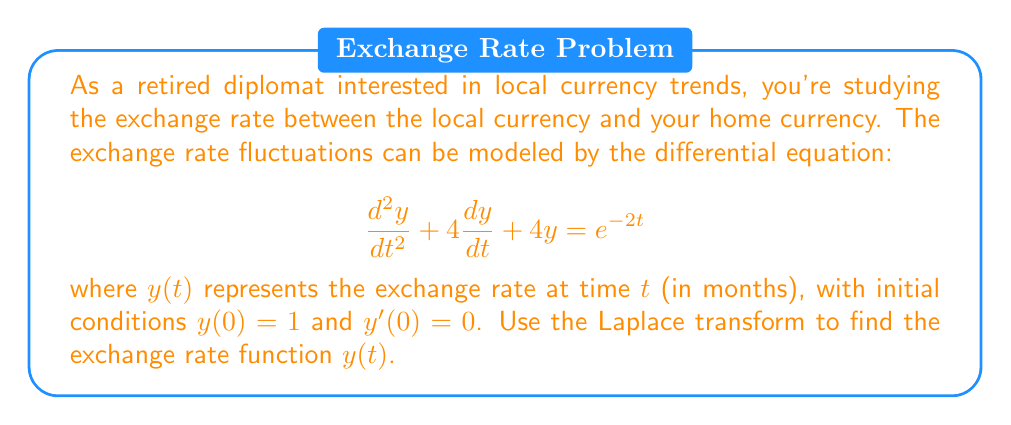Solve this math problem. Let's solve this step-by-step using the Laplace transform:

1) Take the Laplace transform of both sides of the equation:
   $$\mathcal{L}\{\frac{d^2y}{dt^2} + 4\frac{dy}{dt} + 4y\} = \mathcal{L}\{e^{-2t}\}$$

2) Using Laplace transform properties:
   $$[s^2Y(s) - sy(0) - y'(0)] + 4[sY(s) - y(0)] + 4Y(s) = \frac{1}{s+2}$$

3) Substitute the initial conditions $y(0) = 1$ and $y'(0) = 0$:
   $$s^2Y(s) - s + 4sY(s) - 4 + 4Y(s) = \frac{1}{s+2}$$

4) Simplify:
   $$(s^2 + 4s + 4)Y(s) = \frac{1}{s+2} + s + 4$$

5) Factor out $Y(s)$:
   $$Y(s) = \frac{\frac{1}{s+2} + s + 4}{s^2 + 4s + 4}$$

6) Simplify the numerator:
   $$Y(s) = \frac{\frac{s^2 + 6s + 8}{s+2}}{(s+2)^2}$$

7) Perform partial fraction decomposition:
   $$Y(s) = \frac{1}{(s+2)^2} + \frac{1}{s+2}$$

8) Take the inverse Laplace transform:
   $$y(t) = \mathcal{L}^{-1}\{\frac{1}{(s+2)^2} + \frac{1}{s+2}\}$$

9) Using inverse Laplace transform properties:
   $$y(t) = te^{-2t} + e^{-2t}$$

10) Simplify:
    $$y(t) = (t+1)e^{-2t}$$
Answer: $y(t) = (t+1)e^{-2t}$ 